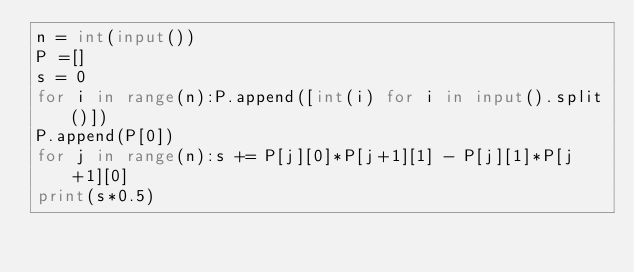<code> <loc_0><loc_0><loc_500><loc_500><_Python_>n = int(input())
P =[]
s = 0
for i in range(n):P.append([int(i) for i in input().split()])
P.append(P[0])
for j in range(n):s += P[j][0]*P[j+1][1] - P[j][1]*P[j+1][0]
print(s*0.5)</code> 